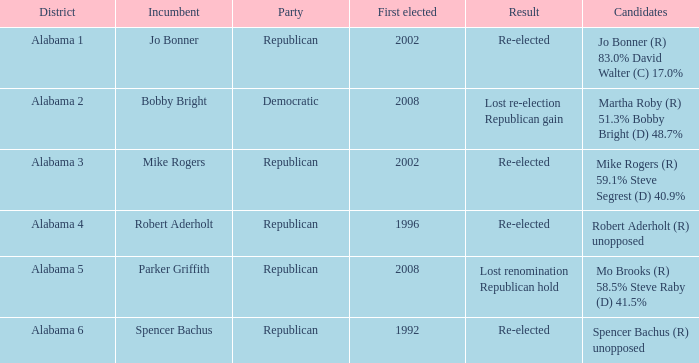Name the incumbent for lost renomination republican hold Parker Griffith. 